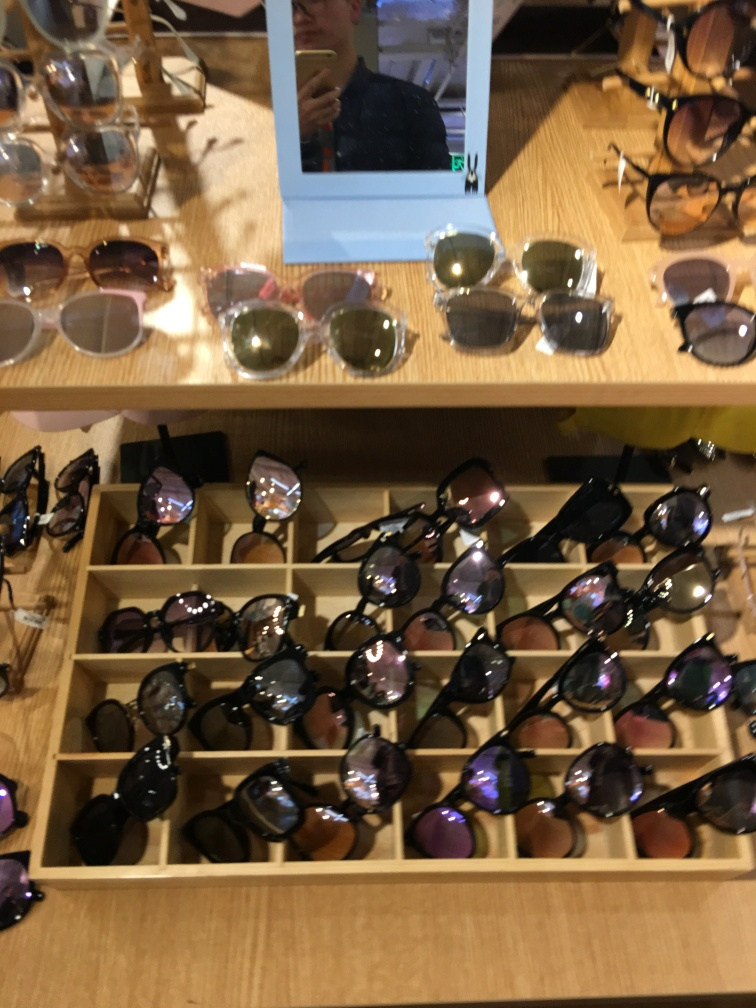What can we infer about the store from this display? The display suggests that the store offers a wide variety of sunglass options, catering to different tastes and needs. The wooden display and orderly arrangement imply an emphasis on presentation, which may indicate a store that values aesthetics and a pleasant shopping experience. Does the reflection in the mirror provide any additional information? The reflection shows a person presumably taking the photo and gives us a glimpse of the store's interior. While details are limited due to the quality of the reflection, it looks like a well-lit environment with more merchandise in the background, hinting at a possibly extensive selection beyond just what is captured in this image. 